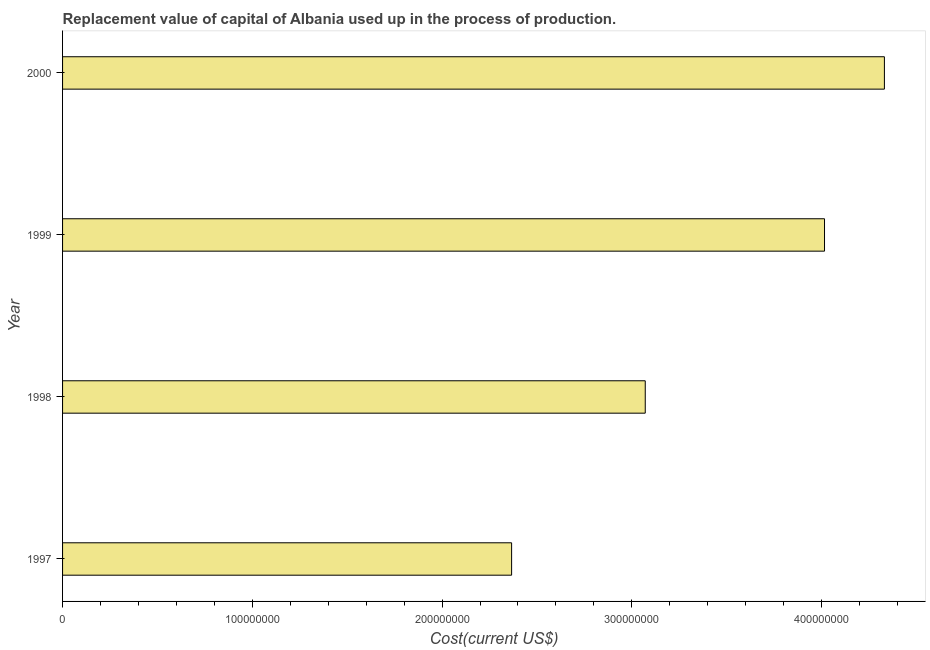What is the title of the graph?
Ensure brevity in your answer.  Replacement value of capital of Albania used up in the process of production. What is the label or title of the X-axis?
Your answer should be very brief. Cost(current US$). What is the label or title of the Y-axis?
Ensure brevity in your answer.  Year. What is the consumption of fixed capital in 1998?
Give a very brief answer. 3.07e+08. Across all years, what is the maximum consumption of fixed capital?
Your answer should be compact. 4.33e+08. Across all years, what is the minimum consumption of fixed capital?
Give a very brief answer. 2.37e+08. In which year was the consumption of fixed capital maximum?
Provide a short and direct response. 2000. What is the sum of the consumption of fixed capital?
Your answer should be very brief. 1.38e+09. What is the difference between the consumption of fixed capital in 1997 and 1999?
Offer a terse response. -1.65e+08. What is the average consumption of fixed capital per year?
Offer a very short reply. 3.45e+08. What is the median consumption of fixed capital?
Make the answer very short. 3.54e+08. What is the ratio of the consumption of fixed capital in 1997 to that in 1999?
Your answer should be very brief. 0.59. Is the consumption of fixed capital in 1998 less than that in 2000?
Keep it short and to the point. Yes. Is the difference between the consumption of fixed capital in 1998 and 2000 greater than the difference between any two years?
Keep it short and to the point. No. What is the difference between the highest and the second highest consumption of fixed capital?
Give a very brief answer. 3.16e+07. Is the sum of the consumption of fixed capital in 1997 and 1998 greater than the maximum consumption of fixed capital across all years?
Make the answer very short. Yes. What is the difference between the highest and the lowest consumption of fixed capital?
Keep it short and to the point. 1.96e+08. In how many years, is the consumption of fixed capital greater than the average consumption of fixed capital taken over all years?
Provide a short and direct response. 2. What is the Cost(current US$) of 1997?
Make the answer very short. 2.37e+08. What is the Cost(current US$) of 1998?
Keep it short and to the point. 3.07e+08. What is the Cost(current US$) of 1999?
Provide a succinct answer. 4.02e+08. What is the Cost(current US$) in 2000?
Your answer should be compact. 4.33e+08. What is the difference between the Cost(current US$) in 1997 and 1998?
Keep it short and to the point. -7.04e+07. What is the difference between the Cost(current US$) in 1997 and 1999?
Offer a very short reply. -1.65e+08. What is the difference between the Cost(current US$) in 1997 and 2000?
Ensure brevity in your answer.  -1.96e+08. What is the difference between the Cost(current US$) in 1998 and 1999?
Your answer should be compact. -9.45e+07. What is the difference between the Cost(current US$) in 1998 and 2000?
Your answer should be compact. -1.26e+08. What is the difference between the Cost(current US$) in 1999 and 2000?
Provide a short and direct response. -3.16e+07. What is the ratio of the Cost(current US$) in 1997 to that in 1998?
Ensure brevity in your answer.  0.77. What is the ratio of the Cost(current US$) in 1997 to that in 1999?
Provide a short and direct response. 0.59. What is the ratio of the Cost(current US$) in 1997 to that in 2000?
Provide a succinct answer. 0.55. What is the ratio of the Cost(current US$) in 1998 to that in 1999?
Keep it short and to the point. 0.77. What is the ratio of the Cost(current US$) in 1998 to that in 2000?
Keep it short and to the point. 0.71. What is the ratio of the Cost(current US$) in 1999 to that in 2000?
Make the answer very short. 0.93. 